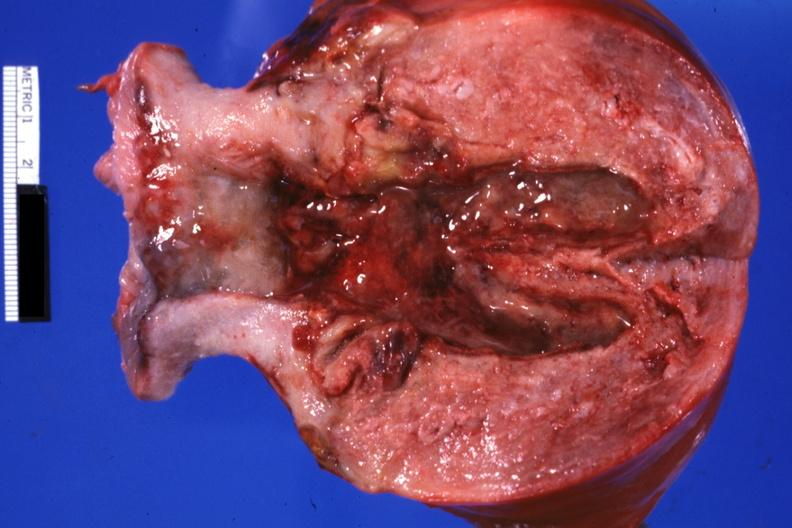s supernumerary digit present?
Answer the question using a single word or phrase. No 